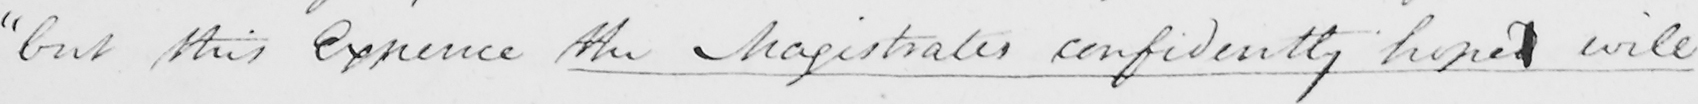Please provide the text content of this handwritten line. " but this Expence the Magistrates confidently hoped will 